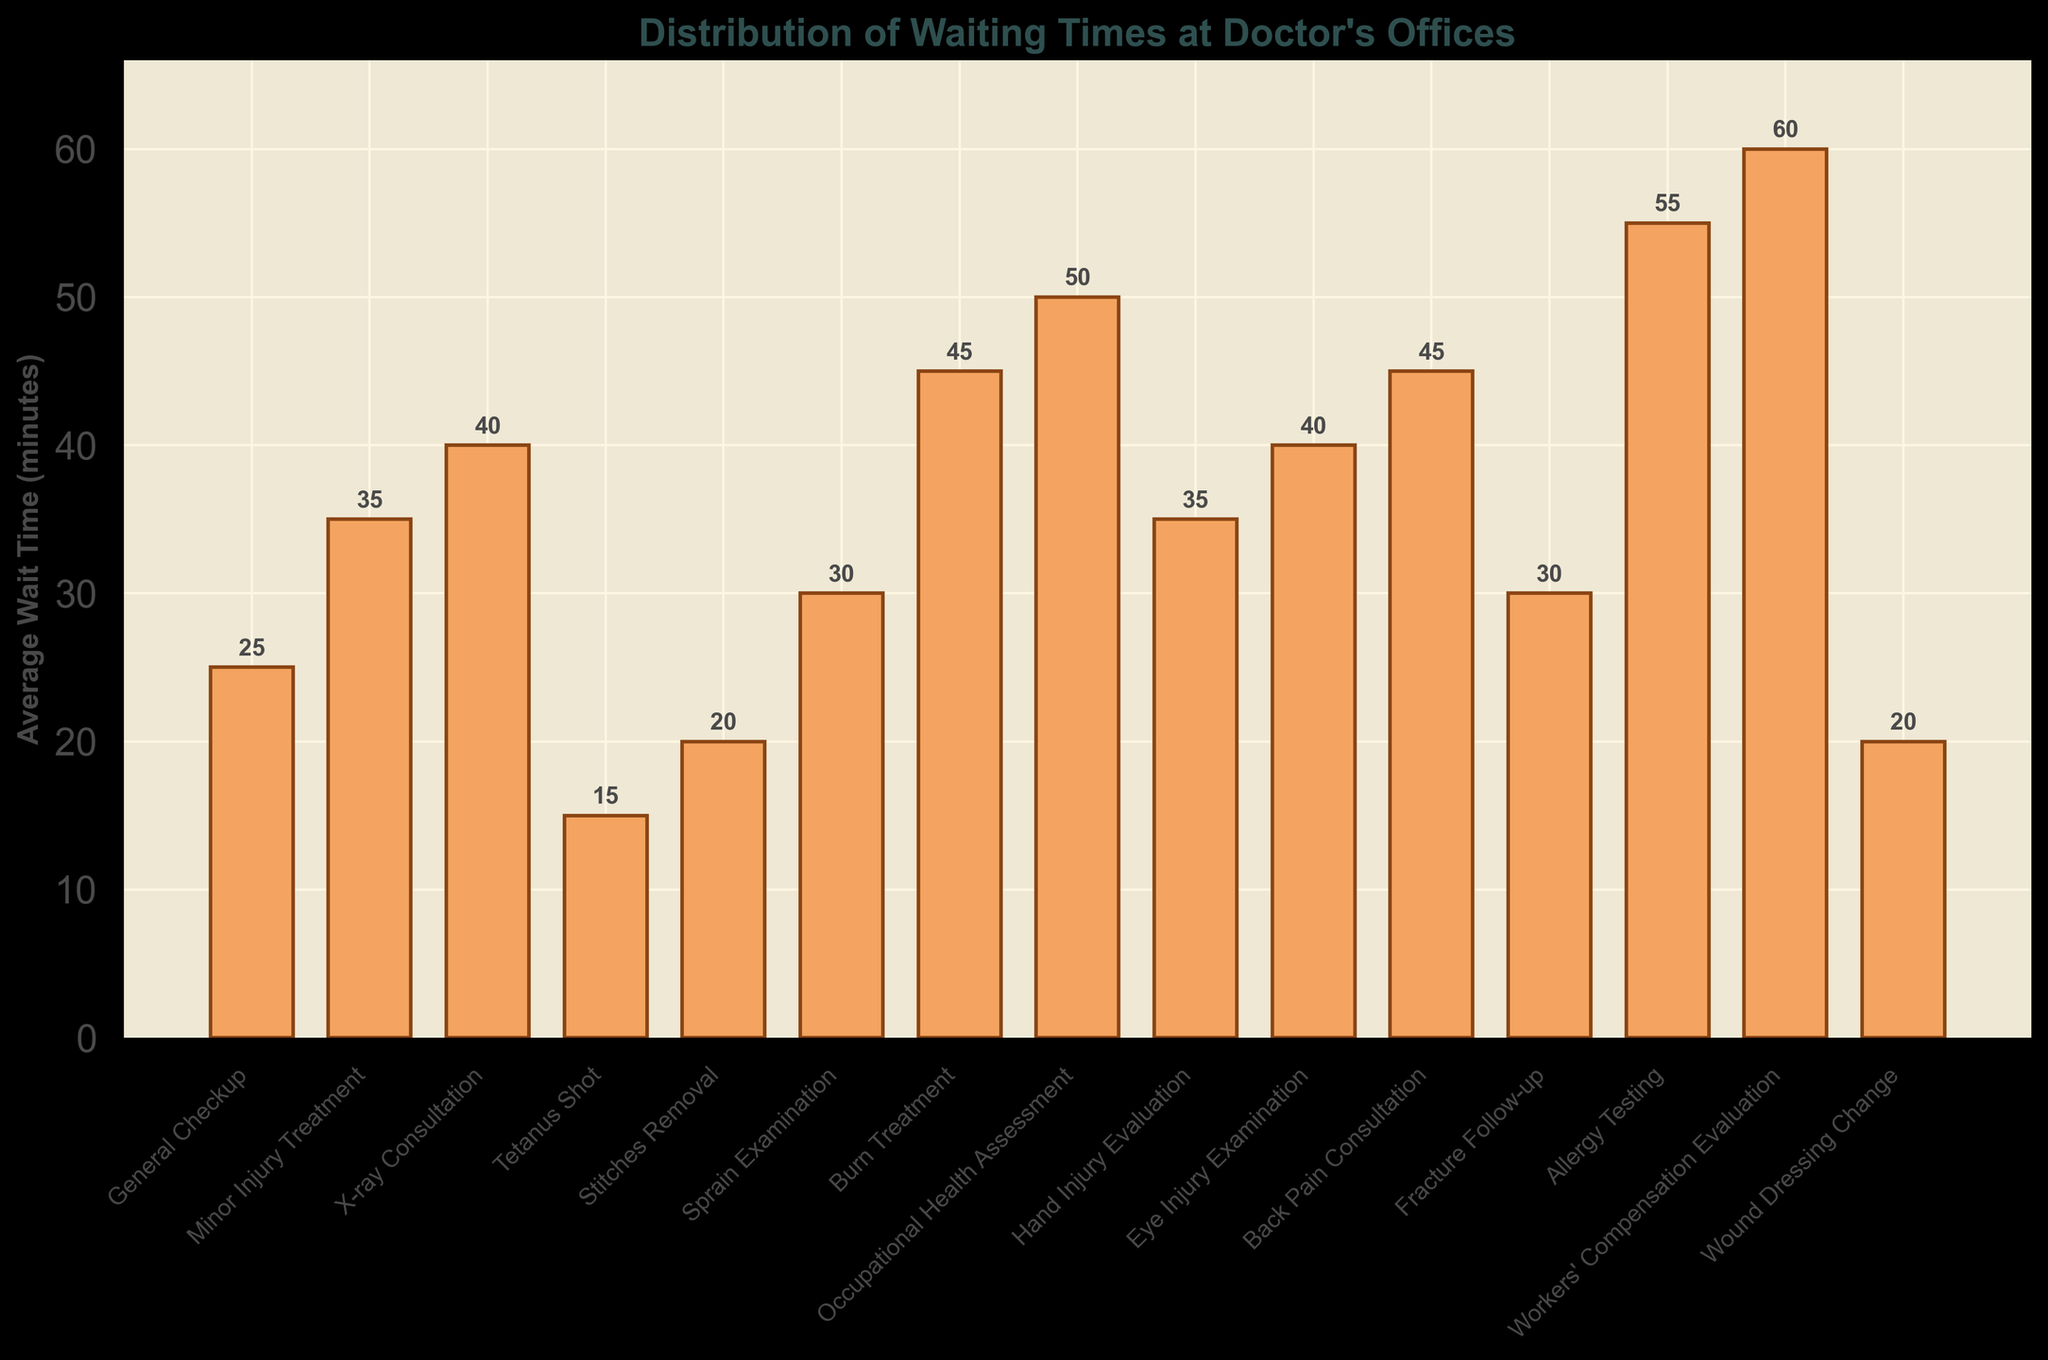What is the average wait time for a Minor Injury Treatment compared to a Tetanus Shot? The bar for Minor Injury Treatment has a value of 35 minutes, while the Tetanus Shot has a value of 15 minutes. Comparing the two, 35 minutes is greater than 15 minutes, so the wait time for a Minor Injury Treatment is longer.
Answer: Minor Injury Treatment wait time is longer Which appointment type has the longest average wait time? The tallest bar indicates the longest wait time, which is Workers' Compensation Evaluation at 60 minutes.
Answer: Workers' Compensation Evaluation What is the difference in average wait time between a Burn Treatment and a General Checkup? The bar for Burn Treatment has a value of 45 minutes, while the General Checkup has 25 minutes. The difference is calculated as 45 - 25 = 20 minutes.
Answer: 20 minutes How does the wait time for an Allergy Testing appointment compare to a Fracture Follow-up? Allergy Testing has a bar corresponding to 55 minutes, whereas Fracture Follow-up is at 30 minutes. Therefore, Allergy Testing has a longer wait time by 25 minutes.
Answer: Allergy Testing is longer by 25 minutes Which two appointment types have the closest average wait times? By comparing the bar heights, Minor Injury Treatment and Hand Injury Evaluation both have a wait time of 35 minutes, which means they are closest to each other.
Answer: Minor Injury Treatment and Hand Injury Evaluation What is the total average wait time for appointments General Checkup, Stitches Removal, and Wound Dressing Change? The values for the appointments are 25, 20, and 20 minutes respectively. Summing them gives 25 + 20 + 20 = 65 minutes.
Answer: 65 minutes Which appointment types have an average wait time of more than 40 minutes? The bar values over 40 minutes are: X-ray Consultation (40 mins), Burn Treatment (45 mins), Eye Injury Examination (40 mins), Back Pain Consultation (45 mins), Allergy Testing (55 mins), and Workers' Compensation Evaluation (60 mins).
Answer: X-ray Consultation, Burn Treatment, Eye Injury Examination, Back Pain Consultation, Allergy Testing, Workers' Compensation Evaluation What's the average of the waiting times for Sprain Examination, Fracture Follow-up, and Back Pain Consultation? Summing the given values: Sprain Examination (30 mins), Fracture Follow-up (30 mins), Back Pain Consultation (45 mins), we get 30 + 30 + 45 = 105. Dividing by 3 to get the average gives 105 / 3 = 35 minutes.
Answer: 35 minutes How many appointment types have a wait time less than 30 minutes? The bars under 30 minutes are for Tetanus Shot (15 mins), Stitches Removal (20 mins), and Wound Dressing Change (20 mins), General Checkup (25 mins). So, there are 4 appointment types.
Answer: 4 appointment types 